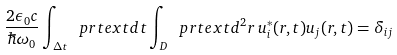Convert formula to latex. <formula><loc_0><loc_0><loc_500><loc_500>\frac { 2 \epsilon _ { 0 } c } { \hbar { \omega } _ { 0 } } \int _ { \Delta t } \ p r t e x t { d } t \int _ { D } \ p r t e x t { d } ^ { 2 } { r } \, { u } _ { i } ^ { \ast } ( { r } , t ) { u } _ { j } ( { r } , t ) = \delta _ { i j }</formula> 